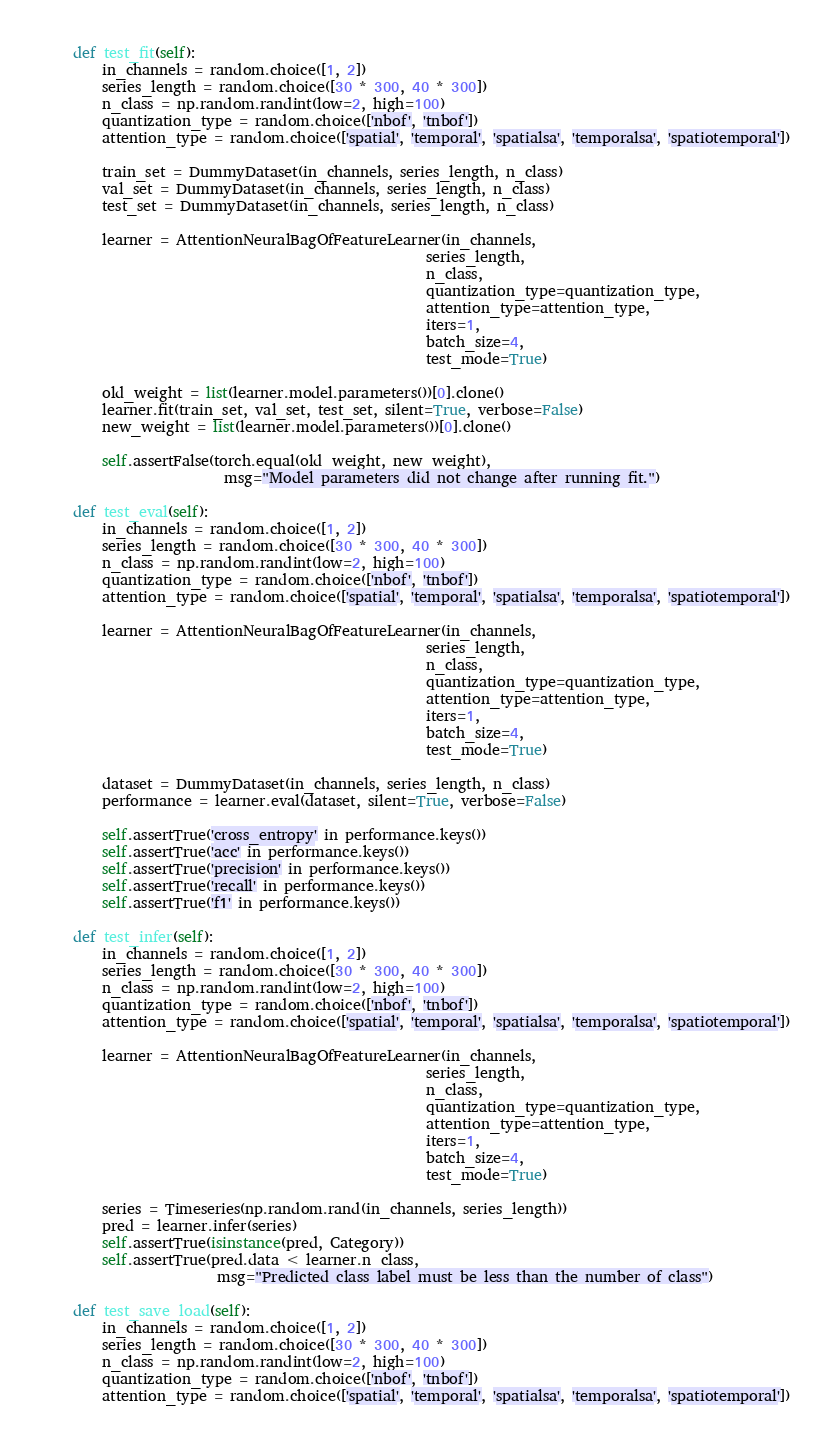<code> <loc_0><loc_0><loc_500><loc_500><_Python_>
    def test_fit(self):
        in_channels = random.choice([1, 2])
        series_length = random.choice([30 * 300, 40 * 300])
        n_class = np.random.randint(low=2, high=100)
        quantization_type = random.choice(['nbof', 'tnbof'])
        attention_type = random.choice(['spatial', 'temporal', 'spatialsa', 'temporalsa', 'spatiotemporal'])

        train_set = DummyDataset(in_channels, series_length, n_class)
        val_set = DummyDataset(in_channels, series_length, n_class)
        test_set = DummyDataset(in_channels, series_length, n_class)

        learner = AttentionNeuralBagOfFeatureLearner(in_channels,
                                                     series_length,
                                                     n_class,
                                                     quantization_type=quantization_type,
                                                     attention_type=attention_type,
                                                     iters=1,
                                                     batch_size=4,
                                                     test_mode=True)

        old_weight = list(learner.model.parameters())[0].clone()
        learner.fit(train_set, val_set, test_set, silent=True, verbose=False)
        new_weight = list(learner.model.parameters())[0].clone()

        self.assertFalse(torch.equal(old_weight, new_weight),
                         msg="Model parameters did not change after running fit.")

    def test_eval(self):
        in_channels = random.choice([1, 2])
        series_length = random.choice([30 * 300, 40 * 300])
        n_class = np.random.randint(low=2, high=100)
        quantization_type = random.choice(['nbof', 'tnbof'])
        attention_type = random.choice(['spatial', 'temporal', 'spatialsa', 'temporalsa', 'spatiotemporal'])

        learner = AttentionNeuralBagOfFeatureLearner(in_channels,
                                                     series_length,
                                                     n_class,
                                                     quantization_type=quantization_type,
                                                     attention_type=attention_type,
                                                     iters=1,
                                                     batch_size=4,
                                                     test_mode=True)

        dataset = DummyDataset(in_channels, series_length, n_class)
        performance = learner.eval(dataset, silent=True, verbose=False)

        self.assertTrue('cross_entropy' in performance.keys())
        self.assertTrue('acc' in performance.keys())
        self.assertTrue('precision' in performance.keys())
        self.assertTrue('recall' in performance.keys())
        self.assertTrue('f1' in performance.keys())

    def test_infer(self):
        in_channels = random.choice([1, 2])
        series_length = random.choice([30 * 300, 40 * 300])
        n_class = np.random.randint(low=2, high=100)
        quantization_type = random.choice(['nbof', 'tnbof'])
        attention_type = random.choice(['spatial', 'temporal', 'spatialsa', 'temporalsa', 'spatiotemporal'])

        learner = AttentionNeuralBagOfFeatureLearner(in_channels,
                                                     series_length,
                                                     n_class,
                                                     quantization_type=quantization_type,
                                                     attention_type=attention_type,
                                                     iters=1,
                                                     batch_size=4,
                                                     test_mode=True)

        series = Timeseries(np.random.rand(in_channels, series_length))
        pred = learner.infer(series)
        self.assertTrue(isinstance(pred, Category))
        self.assertTrue(pred.data < learner.n_class,
                        msg="Predicted class label must be less than the number of class")

    def test_save_load(self):
        in_channels = random.choice([1, 2])
        series_length = random.choice([30 * 300, 40 * 300])
        n_class = np.random.randint(low=2, high=100)
        quantization_type = random.choice(['nbof', 'tnbof'])
        attention_type = random.choice(['spatial', 'temporal', 'spatialsa', 'temporalsa', 'spatiotemporal'])
</code> 